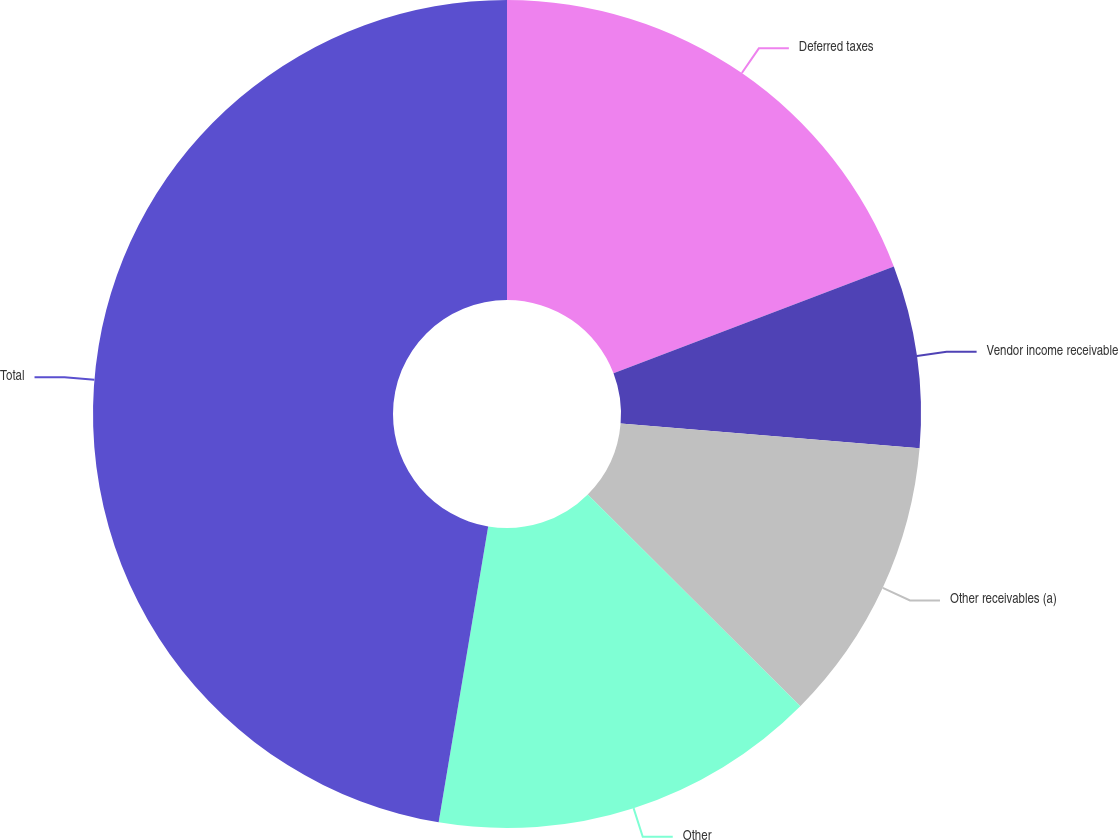<chart> <loc_0><loc_0><loc_500><loc_500><pie_chart><fcel>Deferred taxes<fcel>Vendor income receivable<fcel>Other receivables (a)<fcel>Other<fcel>Total<nl><fcel>19.2%<fcel>7.12%<fcel>11.15%<fcel>15.17%<fcel>47.36%<nl></chart> 